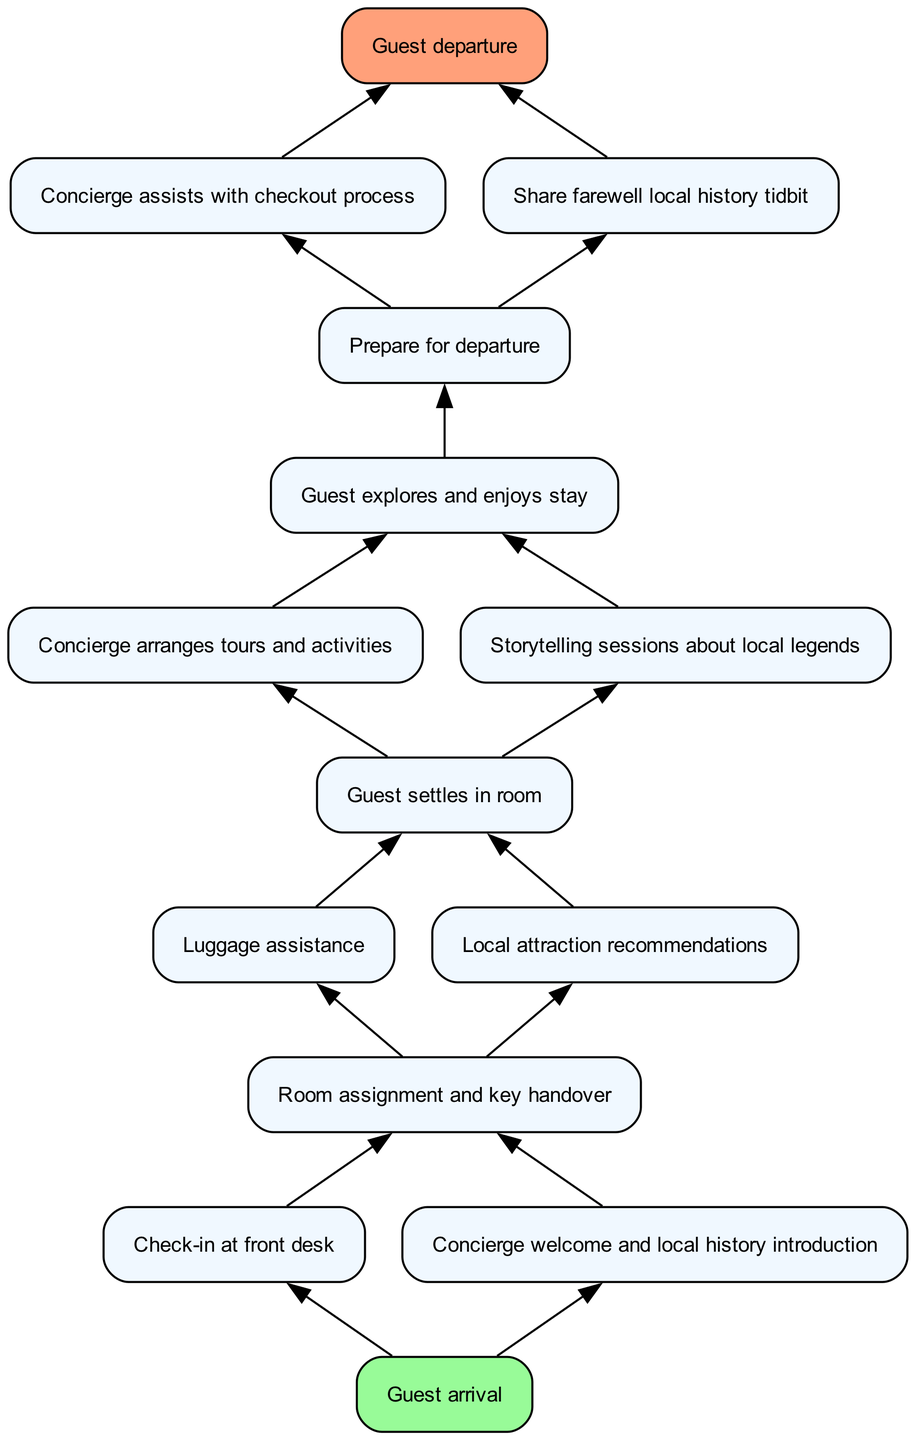What is the first step in the guest's journey? The first step in the guest's journey is represented by the node labeled "Guest arrival," which indicates the beginning of the process.
Answer: Guest arrival How many connections does the "Check-in at front desk" node have? The "Check-in at front desk" node has one connection that leads to "Room assignment and key handover," indicating that this is the next step after check-in.
Answer: 1 What happens after the guest settles in their room? After the guest settles in their room, there are two possible next steps: either "Concierge arranges tours and activities" or "Storytelling sessions about local legends," indicating the activities the guest can engage in.
Answer: Concierge arranges tours and activities or Storytelling sessions about local legends What is the last action taken before the guest departs? The last action taken before the guest departs is represented by the connections to both "Concierge assists with checkout process" and "Share farewell local history tidbit," which are both steps leading up to the final node.
Answer: Concierge assists with checkout process and Share farewell local history tidbit In total, how many nodes are in the diagram? To find the total number of nodes, we can count all the unique actions represented in the diagram, which leads us to a total of 14 distinct nodes included in the guest journey flow.
Answer: 14 Which node is immediately after the "Guest explores and enjoys stay"? The node that follows "Guest explores and enjoys stay" is "Prepare for departure," indicating that after exploring, the guest must prepare for checkout.
Answer: Prepare for departure What types of support does the concierge provide at check-out? At checkout, the concierge assists with the checkout process and shares a farewell local history tidbit, showcasing the concierge's role in both practical and experiential support.
Answer: Concierge assists with checkout process and Share farewell local history tidbit Which two nodes are connected directly to the "Room assignment and key handover"? The two directly connected nodes are "Luggage assistance" and "Local attraction recommendations," indicating the different ways in which the guest can be supported immediately after being assigned a room.
Answer: Luggage assistance and Local attraction recommendations How many actions occur before the "Guest departure"? There are four actions that occur before the "Guest departure": "Prepare for departure," "Concierge assists with checkout process," "Share farewell local history tidbit," and "Guest explores and enjoys stay," indicating the steps involved before leaving.
Answer: 4 